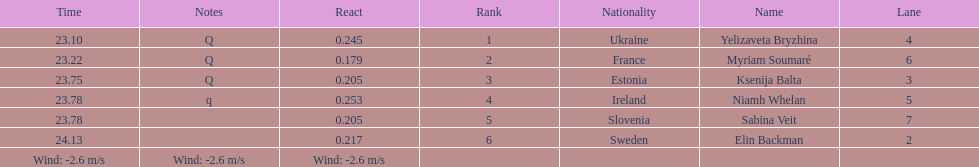Are any of the lanes in consecutive order? No. 